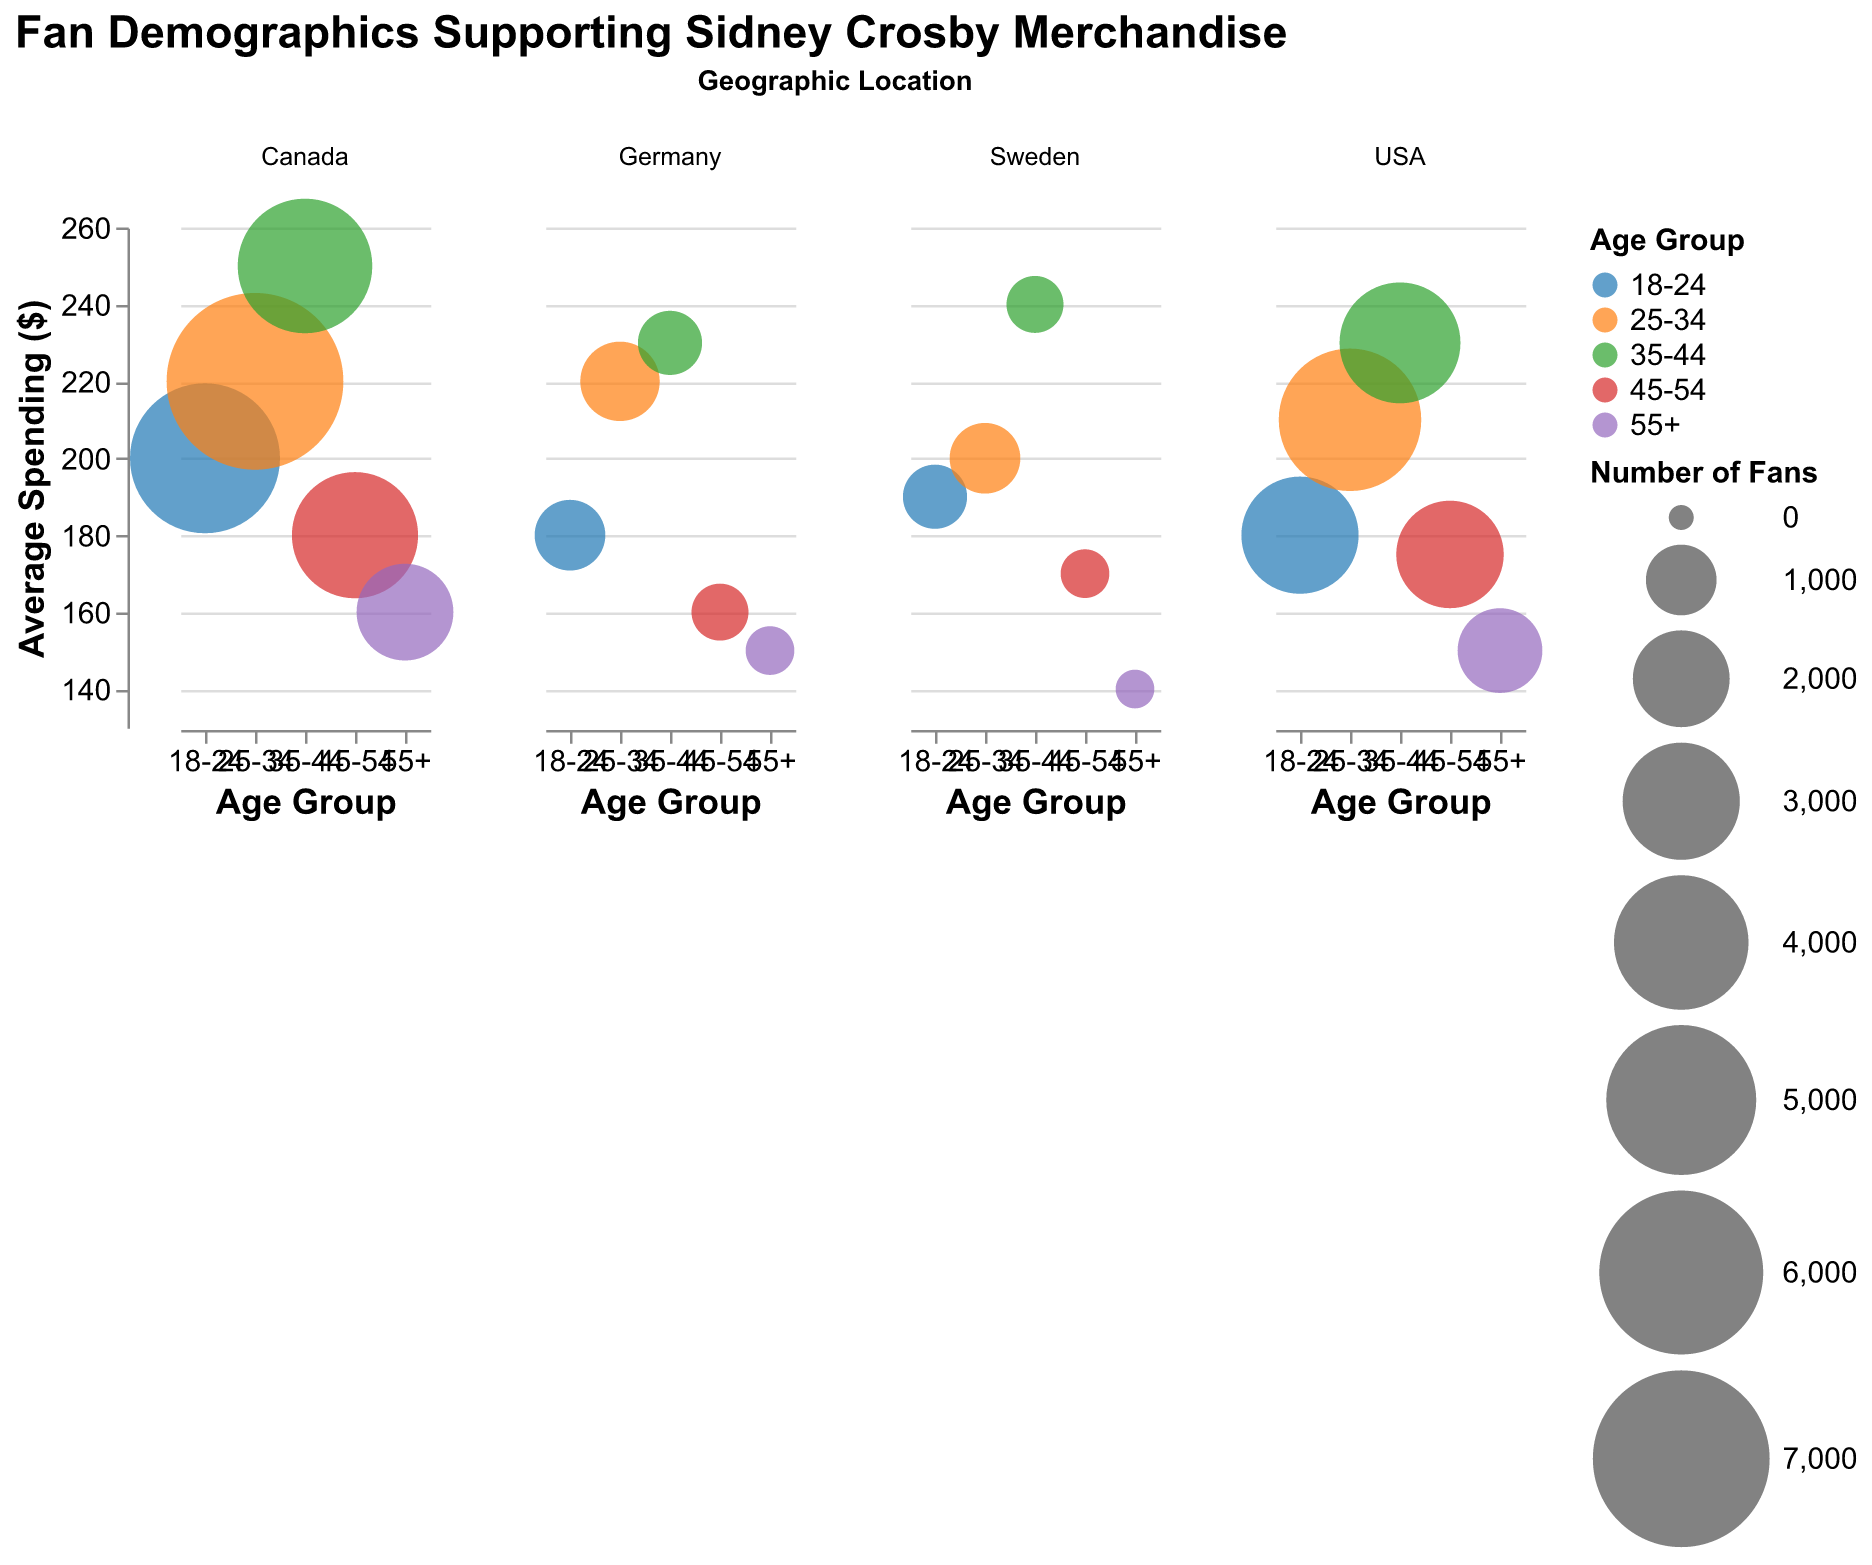Which geographic location has the highest number of fans in the 25-34 age group? Look for the largest bubble in the 25-34 age group across all geographic locations. The largest bubble for the 25-34 age group is found in Canada with 7000 fans.
Answer: Canada What is the average spending on merchandise for USA fans aged 35-44? Find the bubble corresponding to USA fans in the 35-44 age group. The average spending on merchandise for this group is displayed next to the bubble and is $230.
Answer: $230 How many fans are there in the 18-24 age group in Germany, and what is their average spending? Locate the bubble for the 18-24 age group in Germany. The bubble size represents the number of fans, and a tooltip or data point reveals their average spending. Here, there are 1000 fans, each spending $180 on average.
Answer: 1000 fans, $180 Compare the number of fans in the 35-44 age group between Canada and Sweden. Which country has more fans? Identify and compare the bubble sizes for the 35-44 age group in both Canada and Sweden. Canada has 4000 fans in the 35-44 age group, whereas Sweden has 600 fans.
Answer: Canada Which age group in Sweden has the highest average spending on merchandise, and what is that amount? Examine the y-axis position for each age group in Sweden and find the highest value. The 35-44 age group in Sweden has the highest average spending at $240.
Answer: 35-44, $240 What is the total number of fans across all age groups in the USA? Sum the number of fans across all age groups in the USA: 3000 (18-24) + 4500 (25-34) + 3200 (35-44) + 2500 (45-54) + 1500 (55+). The total is 14700 fans.
Answer: 14700 Compare the average spending on merchandise between fans aged 45-54 in the USA and Canada. Which country has higher spending, and by how much? Look at the y-axis values for fans aged 45-54 in both the USA ($175) and Canada ($180). Canada has higher average spending by $5.
Answer: Canada, $5 Which geographic location has the smallest bubble for any age group, and what is its bubble size? Locate the smallest bubble without regard to the age group. The smallest bubble is in Sweden for the 55+ age group with a bubble size of 200.
Answer: Sweden, 200 What is the difference in average spending on merchandise between fans aged 25-34 and those aged 55+ in Germany? Identify the y-axis values for these age groups in Germany: 25-34 ($220) and 55+ ($150). The difference is $220 - $150 = $70.
Answer: $70 Which age groups in Sweden have fans spending on average more than $200 on merchandise? Check the y-axis for each age group in Sweden and identify those above $200. Only the 35-44 age group meets this criterion with an average spending of $240.
Answer: 35-44 